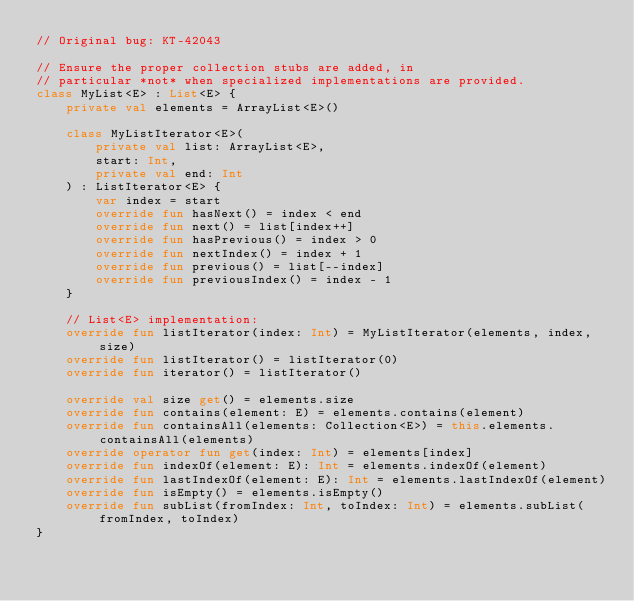<code> <loc_0><loc_0><loc_500><loc_500><_Kotlin_>// Original bug: KT-42043

// Ensure the proper collection stubs are added, in
// particular *not* when specialized implementations are provided.
class MyList<E> : List<E> {
    private val elements = ArrayList<E>()

    class MyListIterator<E>(
        private val list: ArrayList<E>,
        start: Int,
        private val end: Int
    ) : ListIterator<E> {
        var index = start
        override fun hasNext() = index < end
        override fun next() = list[index++]
        override fun hasPrevious() = index > 0
        override fun nextIndex() = index + 1
        override fun previous() = list[--index]
        override fun previousIndex() = index - 1
    }

    // List<E> implementation:
    override fun listIterator(index: Int) = MyListIterator(elements, index, size)
    override fun listIterator() = listIterator(0)
    override fun iterator() = listIterator()

    override val size get() = elements.size
    override fun contains(element: E) = elements.contains(element)
    override fun containsAll(elements: Collection<E>) = this.elements.containsAll(elements)
    override operator fun get(index: Int) = elements[index]
    override fun indexOf(element: E): Int = elements.indexOf(element)
    override fun lastIndexOf(element: E): Int = elements.lastIndexOf(element)
    override fun isEmpty() = elements.isEmpty()
    override fun subList(fromIndex: Int, toIndex: Int) = elements.subList(fromIndex, toIndex)
}
</code> 